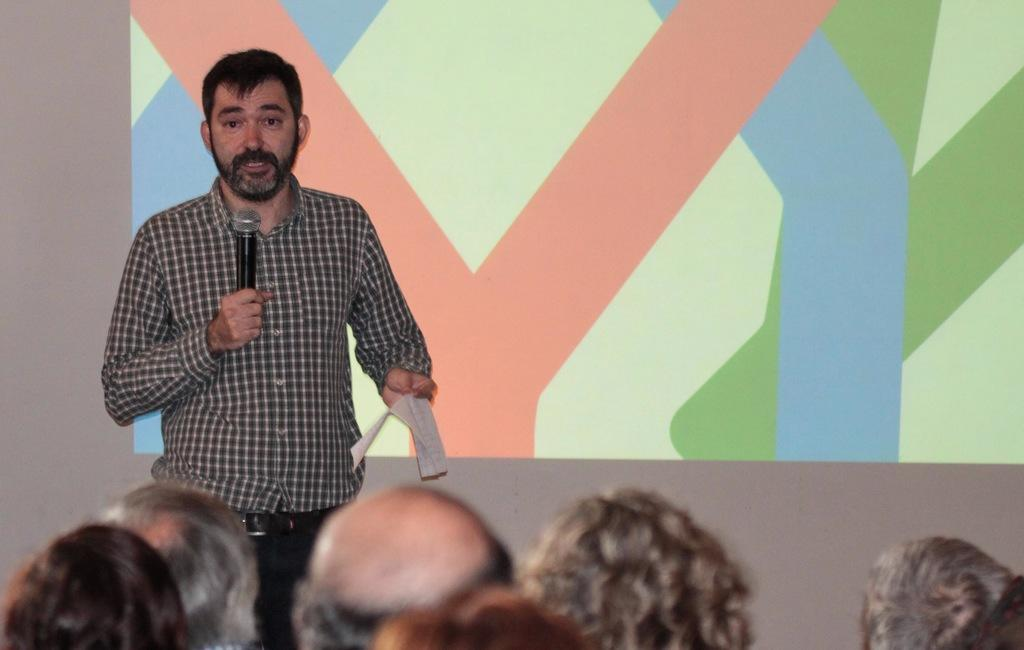What is the general arrangement of people in the image? There is a group of persons sitting and one person standing in the image. What is the standing person wearing? The standing person is wearing a check shirt. What is the standing person holding in his hand? The standing person is holding a microphone and a paper in his hand. Can you see any secretaries in the image? There is no mention of a secretary in the image, so we cannot confirm their presence. Is there a branch visible in the image? There is no mention of a branch in the image, so we cannot confirm its presence. 